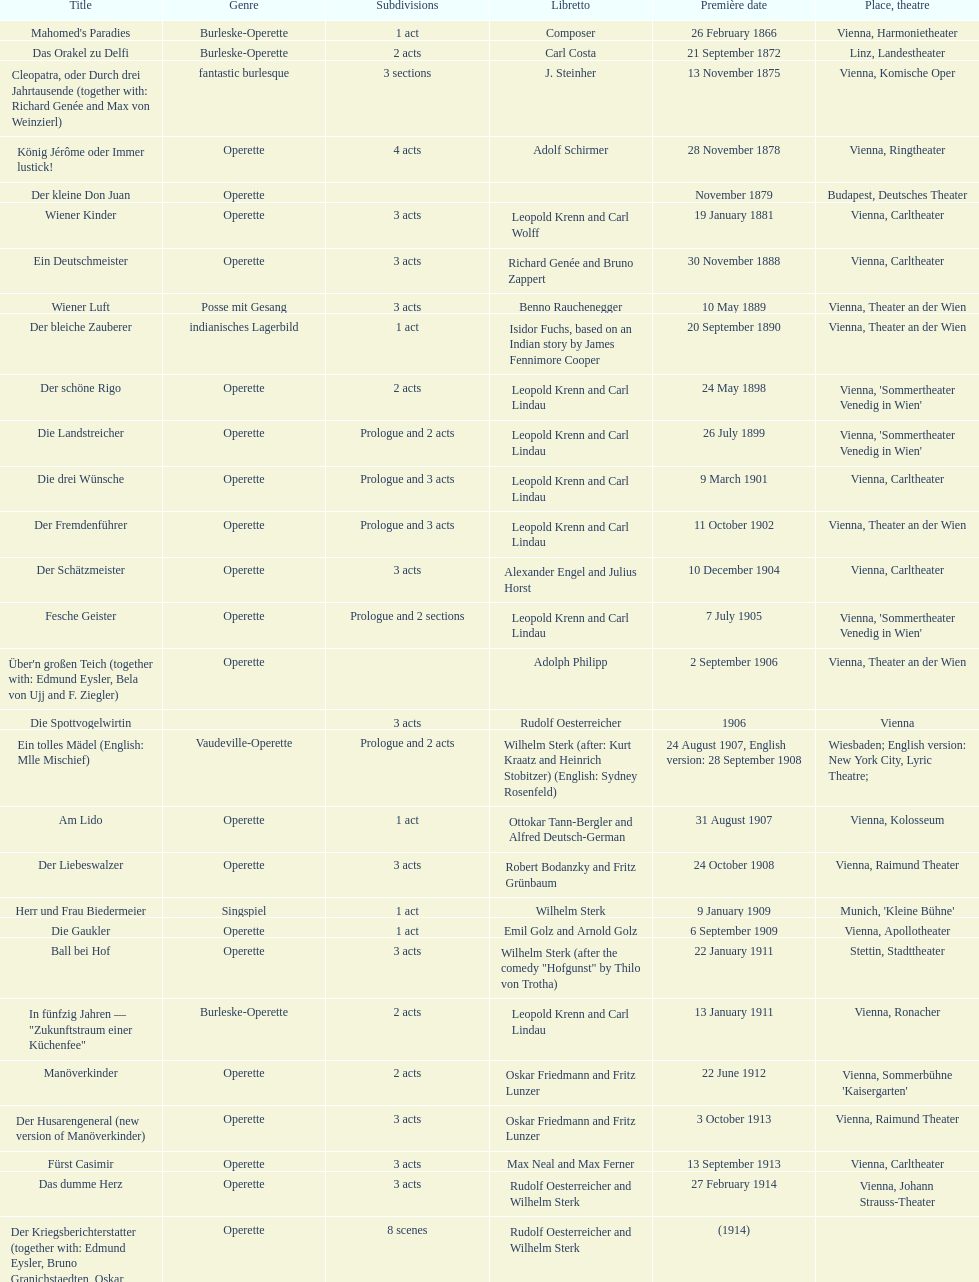In which city did the most operettas premiere? Vienna. 